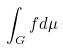Convert formula to latex. <formula><loc_0><loc_0><loc_500><loc_500>\int _ { G } f d \mu</formula> 